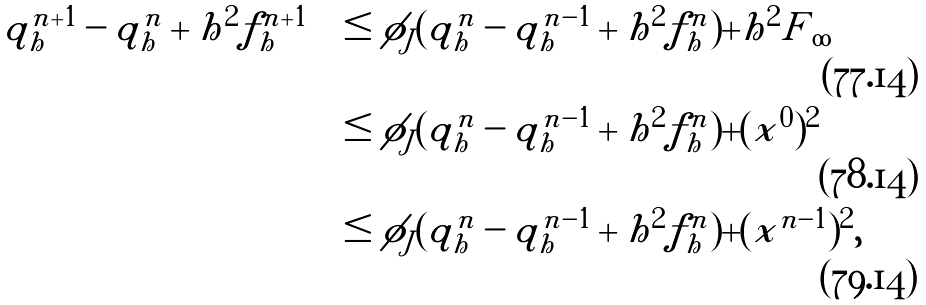Convert formula to latex. <formula><loc_0><loc_0><loc_500><loc_500>| q _ { h } ^ { n + 1 } - q _ { h } ^ { n } | + h ^ { 2 } | f _ { h } ^ { n + 1 } | & \leq \phi _ { J } ( | q _ { h } ^ { n } - q _ { h } ^ { n - 1 } | + h ^ { 2 } | f _ { h } ^ { n } | ) + h ^ { 2 } \| F \| _ { \infty } \\ & \leq \phi _ { J } ( | q _ { h } ^ { n } - q _ { h } ^ { n - 1 } | + h ^ { 2 } | f _ { h } ^ { n } | ) + ( x ^ { 0 } ) ^ { 2 } \\ & \leq \phi _ { J } ( | q _ { h } ^ { n } - q _ { h } ^ { n - 1 } | + h ^ { 2 } | f _ { h } ^ { n } | ) + ( x ^ { n - 1 } ) ^ { 2 } ,</formula> 